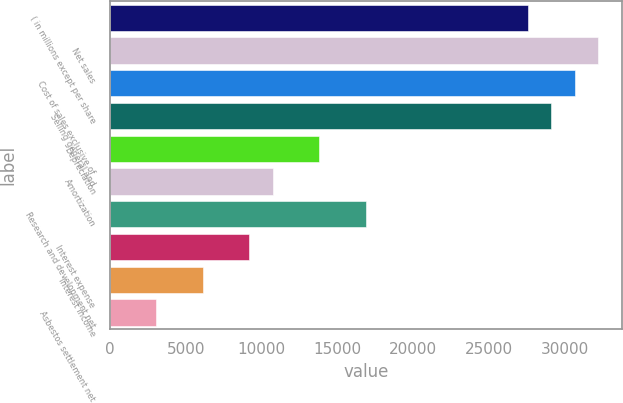<chart> <loc_0><loc_0><loc_500><loc_500><bar_chart><fcel>( in millions except per share<fcel>Net sales<fcel>Cost of sales exclusive of<fcel>Selling general and<fcel>Depreciation<fcel>Amortization<fcel>Research and development net<fcel>Interest expense<fcel>Interest income<fcel>Asbestos settlement net<nl><fcel>27593.2<fcel>32191.9<fcel>30659<fcel>29126.1<fcel>13797.1<fcel>10731.3<fcel>16862.9<fcel>9198.4<fcel>6132.6<fcel>3066.8<nl></chart> 